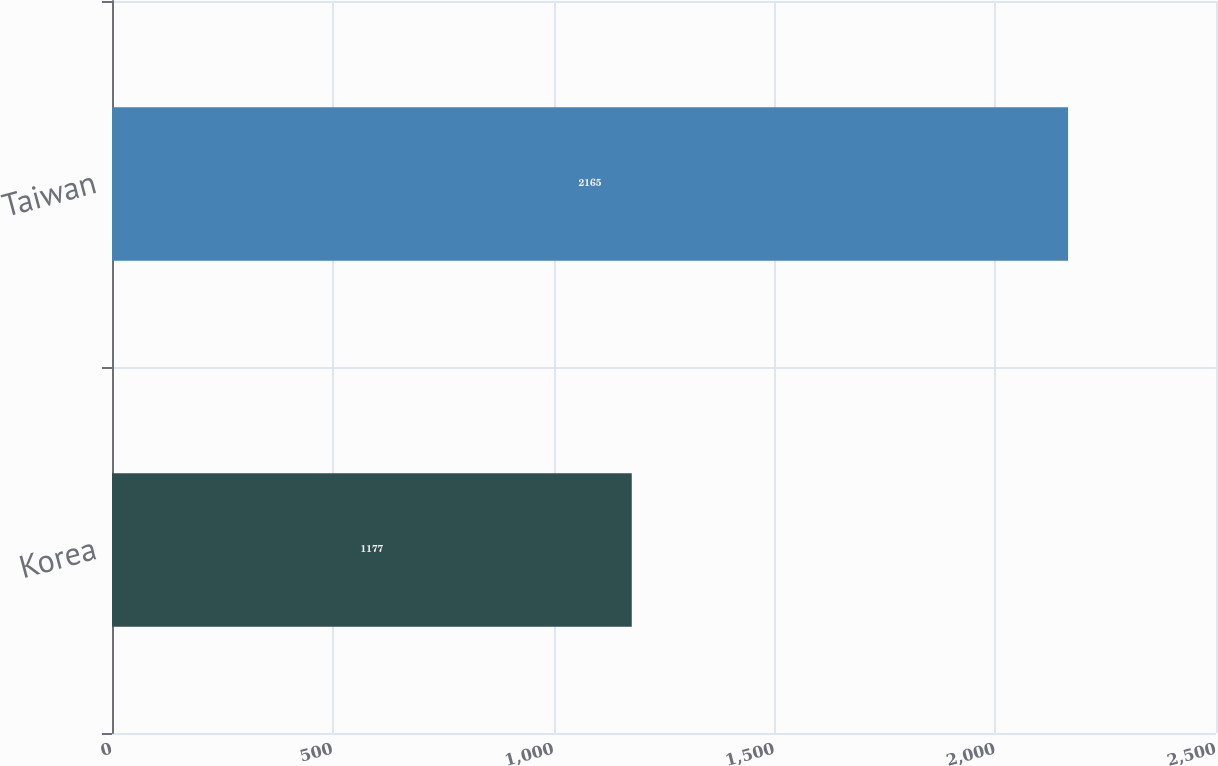Convert chart. <chart><loc_0><loc_0><loc_500><loc_500><bar_chart><fcel>Korea<fcel>Taiwan<nl><fcel>1177<fcel>2165<nl></chart> 